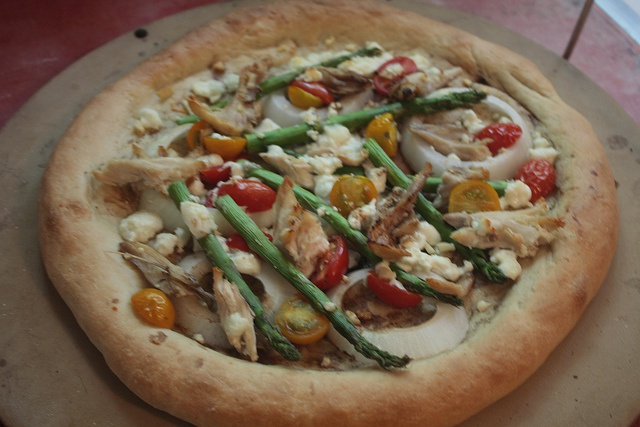Describe the objects in this image and their specific colors. I can see dining table in gray, tan, and maroon tones and pizza in maroon, tan, gray, and darkgray tones in this image. 